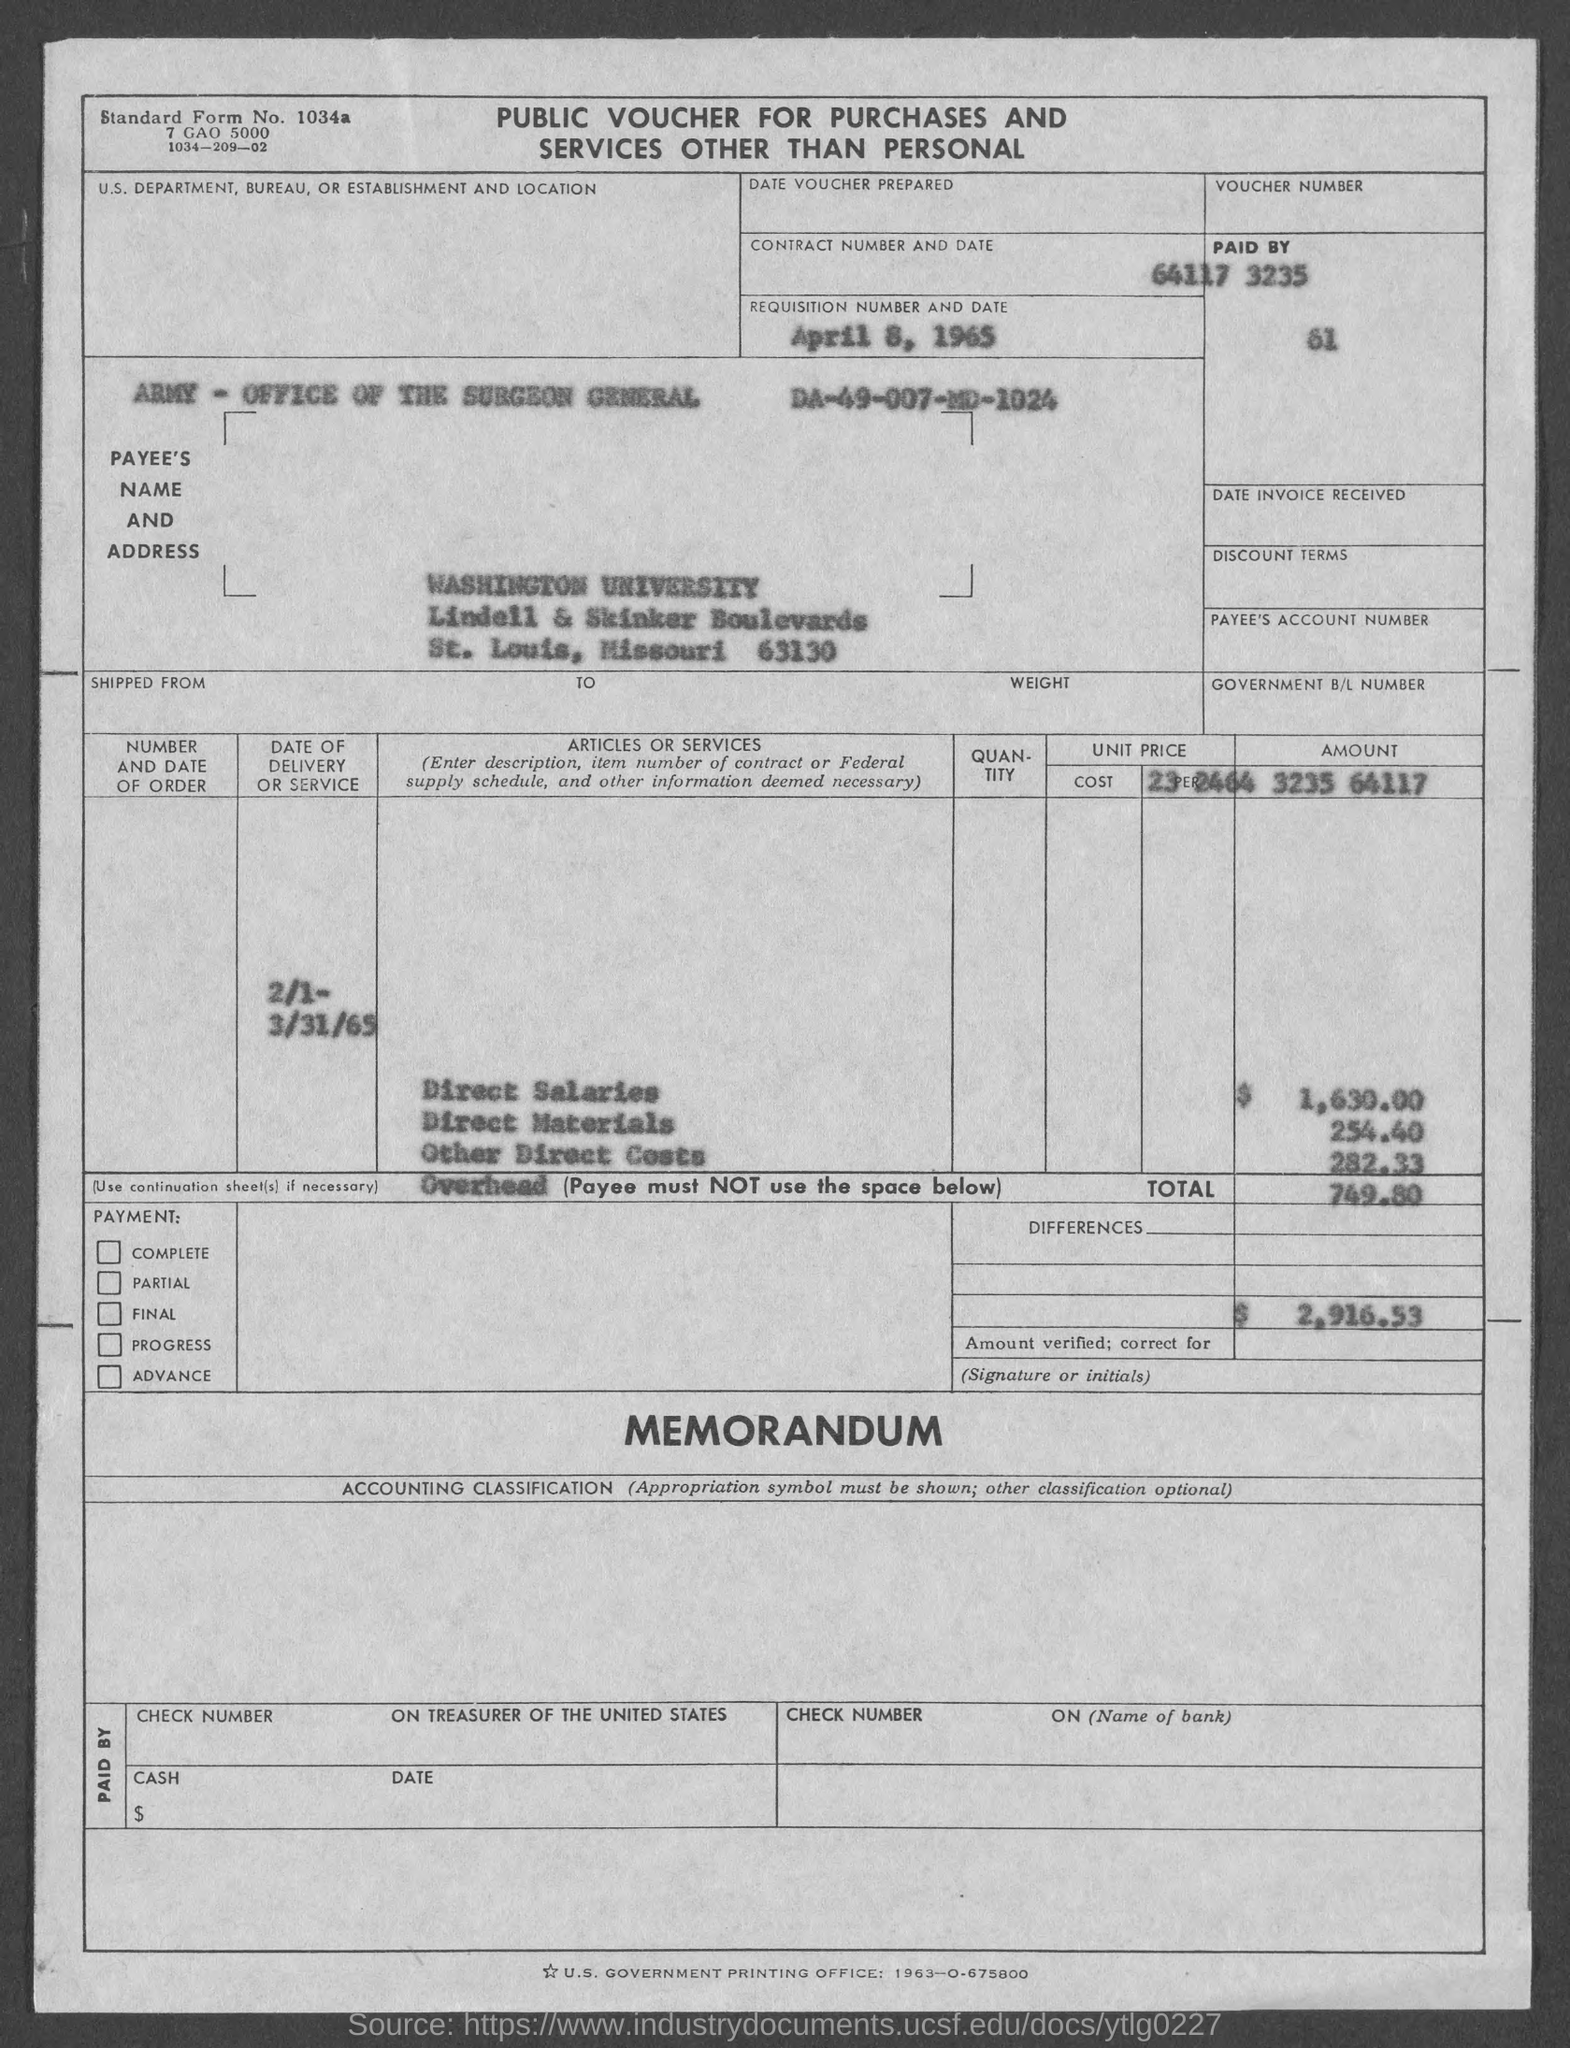Give some essential details in this illustration. This voucher is named 'Public Voucher for Purchases and Services Other Than Personal' What is the standard form number for 1034a...?" is a question asking for information about a specific standard form number. The date of Requisition is April 8, 1965. 